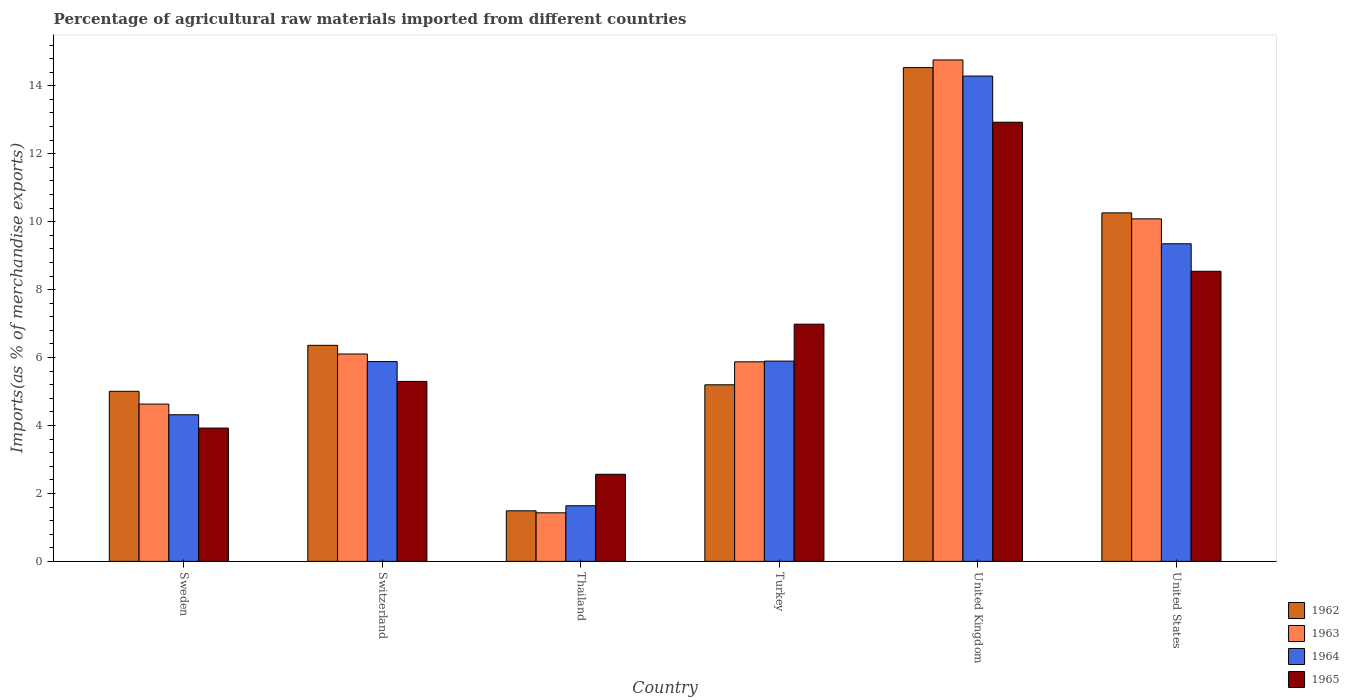How many different coloured bars are there?
Make the answer very short. 4. How many bars are there on the 5th tick from the left?
Provide a succinct answer. 4. What is the percentage of imports to different countries in 1964 in Sweden?
Provide a succinct answer. 4.32. Across all countries, what is the maximum percentage of imports to different countries in 1963?
Provide a short and direct response. 14.76. Across all countries, what is the minimum percentage of imports to different countries in 1964?
Ensure brevity in your answer.  1.64. In which country was the percentage of imports to different countries in 1962 minimum?
Give a very brief answer. Thailand. What is the total percentage of imports to different countries in 1964 in the graph?
Offer a very short reply. 41.37. What is the difference between the percentage of imports to different countries in 1965 in Thailand and that in United States?
Give a very brief answer. -5.98. What is the difference between the percentage of imports to different countries in 1965 in Thailand and the percentage of imports to different countries in 1964 in Sweden?
Offer a very short reply. -1.75. What is the average percentage of imports to different countries in 1962 per country?
Keep it short and to the point. 7.14. What is the difference between the percentage of imports to different countries of/in 1962 and percentage of imports to different countries of/in 1964 in Thailand?
Ensure brevity in your answer.  -0.15. What is the ratio of the percentage of imports to different countries in 1965 in Switzerland to that in Thailand?
Offer a terse response. 2.07. What is the difference between the highest and the second highest percentage of imports to different countries in 1963?
Keep it short and to the point. -4.68. What is the difference between the highest and the lowest percentage of imports to different countries in 1963?
Give a very brief answer. 13.33. Is the sum of the percentage of imports to different countries in 1962 in Sweden and Thailand greater than the maximum percentage of imports to different countries in 1964 across all countries?
Offer a terse response. No. Is it the case that in every country, the sum of the percentage of imports to different countries in 1962 and percentage of imports to different countries in 1964 is greater than the percentage of imports to different countries in 1963?
Offer a terse response. Yes. How many bars are there?
Provide a short and direct response. 24. Are all the bars in the graph horizontal?
Your response must be concise. No. What is the difference between two consecutive major ticks on the Y-axis?
Your response must be concise. 2. Does the graph contain grids?
Keep it short and to the point. No. How are the legend labels stacked?
Offer a terse response. Vertical. What is the title of the graph?
Your answer should be compact. Percentage of agricultural raw materials imported from different countries. What is the label or title of the X-axis?
Ensure brevity in your answer.  Country. What is the label or title of the Y-axis?
Keep it short and to the point. Imports(as % of merchandise exports). What is the Imports(as % of merchandise exports) in 1962 in Sweden?
Keep it short and to the point. 5.01. What is the Imports(as % of merchandise exports) in 1963 in Sweden?
Give a very brief answer. 4.63. What is the Imports(as % of merchandise exports) of 1964 in Sweden?
Provide a succinct answer. 4.32. What is the Imports(as % of merchandise exports) in 1965 in Sweden?
Provide a succinct answer. 3.92. What is the Imports(as % of merchandise exports) in 1962 in Switzerland?
Make the answer very short. 6.36. What is the Imports(as % of merchandise exports) in 1963 in Switzerland?
Your answer should be very brief. 6.1. What is the Imports(as % of merchandise exports) in 1964 in Switzerland?
Ensure brevity in your answer.  5.88. What is the Imports(as % of merchandise exports) of 1965 in Switzerland?
Keep it short and to the point. 5.3. What is the Imports(as % of merchandise exports) in 1962 in Thailand?
Give a very brief answer. 1.49. What is the Imports(as % of merchandise exports) of 1963 in Thailand?
Make the answer very short. 1.43. What is the Imports(as % of merchandise exports) in 1964 in Thailand?
Provide a short and direct response. 1.64. What is the Imports(as % of merchandise exports) in 1965 in Thailand?
Offer a terse response. 2.56. What is the Imports(as % of merchandise exports) in 1962 in Turkey?
Your answer should be very brief. 5.2. What is the Imports(as % of merchandise exports) of 1963 in Turkey?
Give a very brief answer. 5.87. What is the Imports(as % of merchandise exports) of 1964 in Turkey?
Give a very brief answer. 5.9. What is the Imports(as % of merchandise exports) in 1965 in Turkey?
Provide a succinct answer. 6.98. What is the Imports(as % of merchandise exports) of 1962 in United Kingdom?
Provide a succinct answer. 14.54. What is the Imports(as % of merchandise exports) of 1963 in United Kingdom?
Make the answer very short. 14.76. What is the Imports(as % of merchandise exports) in 1964 in United Kingdom?
Make the answer very short. 14.29. What is the Imports(as % of merchandise exports) of 1965 in United Kingdom?
Your answer should be compact. 12.93. What is the Imports(as % of merchandise exports) of 1962 in United States?
Your answer should be compact. 10.26. What is the Imports(as % of merchandise exports) in 1963 in United States?
Offer a terse response. 10.08. What is the Imports(as % of merchandise exports) in 1964 in United States?
Offer a terse response. 9.35. What is the Imports(as % of merchandise exports) in 1965 in United States?
Keep it short and to the point. 8.54. Across all countries, what is the maximum Imports(as % of merchandise exports) of 1962?
Your answer should be very brief. 14.54. Across all countries, what is the maximum Imports(as % of merchandise exports) in 1963?
Offer a very short reply. 14.76. Across all countries, what is the maximum Imports(as % of merchandise exports) in 1964?
Keep it short and to the point. 14.29. Across all countries, what is the maximum Imports(as % of merchandise exports) of 1965?
Your response must be concise. 12.93. Across all countries, what is the minimum Imports(as % of merchandise exports) of 1962?
Provide a short and direct response. 1.49. Across all countries, what is the minimum Imports(as % of merchandise exports) in 1963?
Your answer should be compact. 1.43. Across all countries, what is the minimum Imports(as % of merchandise exports) in 1964?
Ensure brevity in your answer.  1.64. Across all countries, what is the minimum Imports(as % of merchandise exports) of 1965?
Offer a terse response. 2.56. What is the total Imports(as % of merchandise exports) in 1962 in the graph?
Offer a terse response. 42.85. What is the total Imports(as % of merchandise exports) of 1963 in the graph?
Offer a terse response. 42.88. What is the total Imports(as % of merchandise exports) of 1964 in the graph?
Offer a terse response. 41.37. What is the total Imports(as % of merchandise exports) of 1965 in the graph?
Your response must be concise. 40.24. What is the difference between the Imports(as % of merchandise exports) in 1962 in Sweden and that in Switzerland?
Your answer should be very brief. -1.35. What is the difference between the Imports(as % of merchandise exports) in 1963 in Sweden and that in Switzerland?
Your response must be concise. -1.47. What is the difference between the Imports(as % of merchandise exports) of 1964 in Sweden and that in Switzerland?
Ensure brevity in your answer.  -1.57. What is the difference between the Imports(as % of merchandise exports) in 1965 in Sweden and that in Switzerland?
Your response must be concise. -1.37. What is the difference between the Imports(as % of merchandise exports) of 1962 in Sweden and that in Thailand?
Give a very brief answer. 3.52. What is the difference between the Imports(as % of merchandise exports) in 1963 in Sweden and that in Thailand?
Your answer should be very brief. 3.2. What is the difference between the Imports(as % of merchandise exports) of 1964 in Sweden and that in Thailand?
Your answer should be very brief. 2.68. What is the difference between the Imports(as % of merchandise exports) in 1965 in Sweden and that in Thailand?
Make the answer very short. 1.36. What is the difference between the Imports(as % of merchandise exports) of 1962 in Sweden and that in Turkey?
Provide a short and direct response. -0.19. What is the difference between the Imports(as % of merchandise exports) of 1963 in Sweden and that in Turkey?
Your answer should be compact. -1.24. What is the difference between the Imports(as % of merchandise exports) of 1964 in Sweden and that in Turkey?
Your answer should be very brief. -1.58. What is the difference between the Imports(as % of merchandise exports) in 1965 in Sweden and that in Turkey?
Give a very brief answer. -3.06. What is the difference between the Imports(as % of merchandise exports) of 1962 in Sweden and that in United Kingdom?
Offer a terse response. -9.53. What is the difference between the Imports(as % of merchandise exports) of 1963 in Sweden and that in United Kingdom?
Provide a short and direct response. -10.13. What is the difference between the Imports(as % of merchandise exports) of 1964 in Sweden and that in United Kingdom?
Offer a terse response. -9.97. What is the difference between the Imports(as % of merchandise exports) in 1965 in Sweden and that in United Kingdom?
Offer a terse response. -9. What is the difference between the Imports(as % of merchandise exports) of 1962 in Sweden and that in United States?
Offer a terse response. -5.25. What is the difference between the Imports(as % of merchandise exports) of 1963 in Sweden and that in United States?
Provide a succinct answer. -5.45. What is the difference between the Imports(as % of merchandise exports) in 1964 in Sweden and that in United States?
Your answer should be compact. -5.03. What is the difference between the Imports(as % of merchandise exports) in 1965 in Sweden and that in United States?
Offer a terse response. -4.62. What is the difference between the Imports(as % of merchandise exports) in 1962 in Switzerland and that in Thailand?
Offer a terse response. 4.87. What is the difference between the Imports(as % of merchandise exports) in 1963 in Switzerland and that in Thailand?
Your response must be concise. 4.68. What is the difference between the Imports(as % of merchandise exports) in 1964 in Switzerland and that in Thailand?
Offer a terse response. 4.24. What is the difference between the Imports(as % of merchandise exports) of 1965 in Switzerland and that in Thailand?
Make the answer very short. 2.73. What is the difference between the Imports(as % of merchandise exports) in 1962 in Switzerland and that in Turkey?
Give a very brief answer. 1.16. What is the difference between the Imports(as % of merchandise exports) of 1963 in Switzerland and that in Turkey?
Provide a succinct answer. 0.23. What is the difference between the Imports(as % of merchandise exports) in 1964 in Switzerland and that in Turkey?
Your answer should be compact. -0.01. What is the difference between the Imports(as % of merchandise exports) in 1965 in Switzerland and that in Turkey?
Your response must be concise. -1.69. What is the difference between the Imports(as % of merchandise exports) in 1962 in Switzerland and that in United Kingdom?
Your response must be concise. -8.18. What is the difference between the Imports(as % of merchandise exports) of 1963 in Switzerland and that in United Kingdom?
Ensure brevity in your answer.  -8.66. What is the difference between the Imports(as % of merchandise exports) in 1964 in Switzerland and that in United Kingdom?
Offer a very short reply. -8.41. What is the difference between the Imports(as % of merchandise exports) of 1965 in Switzerland and that in United Kingdom?
Give a very brief answer. -7.63. What is the difference between the Imports(as % of merchandise exports) in 1962 in Switzerland and that in United States?
Give a very brief answer. -3.9. What is the difference between the Imports(as % of merchandise exports) of 1963 in Switzerland and that in United States?
Offer a terse response. -3.98. What is the difference between the Imports(as % of merchandise exports) in 1964 in Switzerland and that in United States?
Your response must be concise. -3.47. What is the difference between the Imports(as % of merchandise exports) of 1965 in Switzerland and that in United States?
Ensure brevity in your answer.  -3.24. What is the difference between the Imports(as % of merchandise exports) of 1962 in Thailand and that in Turkey?
Provide a short and direct response. -3.71. What is the difference between the Imports(as % of merchandise exports) of 1963 in Thailand and that in Turkey?
Offer a terse response. -4.45. What is the difference between the Imports(as % of merchandise exports) in 1964 in Thailand and that in Turkey?
Your response must be concise. -4.26. What is the difference between the Imports(as % of merchandise exports) in 1965 in Thailand and that in Turkey?
Provide a succinct answer. -4.42. What is the difference between the Imports(as % of merchandise exports) of 1962 in Thailand and that in United Kingdom?
Your answer should be very brief. -13.05. What is the difference between the Imports(as % of merchandise exports) of 1963 in Thailand and that in United Kingdom?
Your answer should be compact. -13.33. What is the difference between the Imports(as % of merchandise exports) of 1964 in Thailand and that in United Kingdom?
Provide a succinct answer. -12.65. What is the difference between the Imports(as % of merchandise exports) in 1965 in Thailand and that in United Kingdom?
Keep it short and to the point. -10.36. What is the difference between the Imports(as % of merchandise exports) of 1962 in Thailand and that in United States?
Your answer should be compact. -8.77. What is the difference between the Imports(as % of merchandise exports) of 1963 in Thailand and that in United States?
Your answer should be very brief. -8.65. What is the difference between the Imports(as % of merchandise exports) in 1964 in Thailand and that in United States?
Offer a terse response. -7.71. What is the difference between the Imports(as % of merchandise exports) of 1965 in Thailand and that in United States?
Your response must be concise. -5.98. What is the difference between the Imports(as % of merchandise exports) of 1962 in Turkey and that in United Kingdom?
Provide a succinct answer. -9.34. What is the difference between the Imports(as % of merchandise exports) of 1963 in Turkey and that in United Kingdom?
Your answer should be compact. -8.89. What is the difference between the Imports(as % of merchandise exports) of 1964 in Turkey and that in United Kingdom?
Provide a succinct answer. -8.39. What is the difference between the Imports(as % of merchandise exports) in 1965 in Turkey and that in United Kingdom?
Your answer should be very brief. -5.95. What is the difference between the Imports(as % of merchandise exports) in 1962 in Turkey and that in United States?
Provide a succinct answer. -5.06. What is the difference between the Imports(as % of merchandise exports) in 1963 in Turkey and that in United States?
Offer a terse response. -4.21. What is the difference between the Imports(as % of merchandise exports) of 1964 in Turkey and that in United States?
Provide a succinct answer. -3.46. What is the difference between the Imports(as % of merchandise exports) in 1965 in Turkey and that in United States?
Your answer should be very brief. -1.56. What is the difference between the Imports(as % of merchandise exports) of 1962 in United Kingdom and that in United States?
Offer a terse response. 4.28. What is the difference between the Imports(as % of merchandise exports) of 1963 in United Kingdom and that in United States?
Keep it short and to the point. 4.68. What is the difference between the Imports(as % of merchandise exports) of 1964 in United Kingdom and that in United States?
Provide a short and direct response. 4.94. What is the difference between the Imports(as % of merchandise exports) in 1965 in United Kingdom and that in United States?
Your response must be concise. 4.39. What is the difference between the Imports(as % of merchandise exports) in 1962 in Sweden and the Imports(as % of merchandise exports) in 1963 in Switzerland?
Give a very brief answer. -1.1. What is the difference between the Imports(as % of merchandise exports) of 1962 in Sweden and the Imports(as % of merchandise exports) of 1964 in Switzerland?
Your answer should be very brief. -0.88. What is the difference between the Imports(as % of merchandise exports) of 1962 in Sweden and the Imports(as % of merchandise exports) of 1965 in Switzerland?
Offer a very short reply. -0.29. What is the difference between the Imports(as % of merchandise exports) of 1963 in Sweden and the Imports(as % of merchandise exports) of 1964 in Switzerland?
Your answer should be compact. -1.25. What is the difference between the Imports(as % of merchandise exports) of 1963 in Sweden and the Imports(as % of merchandise exports) of 1965 in Switzerland?
Give a very brief answer. -0.67. What is the difference between the Imports(as % of merchandise exports) of 1964 in Sweden and the Imports(as % of merchandise exports) of 1965 in Switzerland?
Provide a succinct answer. -0.98. What is the difference between the Imports(as % of merchandise exports) of 1962 in Sweden and the Imports(as % of merchandise exports) of 1963 in Thailand?
Give a very brief answer. 3.58. What is the difference between the Imports(as % of merchandise exports) in 1962 in Sweden and the Imports(as % of merchandise exports) in 1964 in Thailand?
Your answer should be compact. 3.37. What is the difference between the Imports(as % of merchandise exports) in 1962 in Sweden and the Imports(as % of merchandise exports) in 1965 in Thailand?
Offer a terse response. 2.44. What is the difference between the Imports(as % of merchandise exports) in 1963 in Sweden and the Imports(as % of merchandise exports) in 1964 in Thailand?
Make the answer very short. 2.99. What is the difference between the Imports(as % of merchandise exports) in 1963 in Sweden and the Imports(as % of merchandise exports) in 1965 in Thailand?
Give a very brief answer. 2.07. What is the difference between the Imports(as % of merchandise exports) in 1964 in Sweden and the Imports(as % of merchandise exports) in 1965 in Thailand?
Your response must be concise. 1.75. What is the difference between the Imports(as % of merchandise exports) of 1962 in Sweden and the Imports(as % of merchandise exports) of 1963 in Turkey?
Keep it short and to the point. -0.87. What is the difference between the Imports(as % of merchandise exports) in 1962 in Sweden and the Imports(as % of merchandise exports) in 1964 in Turkey?
Give a very brief answer. -0.89. What is the difference between the Imports(as % of merchandise exports) in 1962 in Sweden and the Imports(as % of merchandise exports) in 1965 in Turkey?
Provide a succinct answer. -1.98. What is the difference between the Imports(as % of merchandise exports) of 1963 in Sweden and the Imports(as % of merchandise exports) of 1964 in Turkey?
Your response must be concise. -1.27. What is the difference between the Imports(as % of merchandise exports) of 1963 in Sweden and the Imports(as % of merchandise exports) of 1965 in Turkey?
Ensure brevity in your answer.  -2.35. What is the difference between the Imports(as % of merchandise exports) in 1964 in Sweden and the Imports(as % of merchandise exports) in 1965 in Turkey?
Give a very brief answer. -2.67. What is the difference between the Imports(as % of merchandise exports) in 1962 in Sweden and the Imports(as % of merchandise exports) in 1963 in United Kingdom?
Offer a very short reply. -9.76. What is the difference between the Imports(as % of merchandise exports) in 1962 in Sweden and the Imports(as % of merchandise exports) in 1964 in United Kingdom?
Keep it short and to the point. -9.28. What is the difference between the Imports(as % of merchandise exports) in 1962 in Sweden and the Imports(as % of merchandise exports) in 1965 in United Kingdom?
Provide a short and direct response. -7.92. What is the difference between the Imports(as % of merchandise exports) of 1963 in Sweden and the Imports(as % of merchandise exports) of 1964 in United Kingdom?
Your answer should be compact. -9.66. What is the difference between the Imports(as % of merchandise exports) of 1963 in Sweden and the Imports(as % of merchandise exports) of 1965 in United Kingdom?
Provide a short and direct response. -8.3. What is the difference between the Imports(as % of merchandise exports) of 1964 in Sweden and the Imports(as % of merchandise exports) of 1965 in United Kingdom?
Provide a succinct answer. -8.61. What is the difference between the Imports(as % of merchandise exports) in 1962 in Sweden and the Imports(as % of merchandise exports) in 1963 in United States?
Offer a very short reply. -5.08. What is the difference between the Imports(as % of merchandise exports) in 1962 in Sweden and the Imports(as % of merchandise exports) in 1964 in United States?
Keep it short and to the point. -4.34. What is the difference between the Imports(as % of merchandise exports) of 1962 in Sweden and the Imports(as % of merchandise exports) of 1965 in United States?
Make the answer very short. -3.53. What is the difference between the Imports(as % of merchandise exports) of 1963 in Sweden and the Imports(as % of merchandise exports) of 1964 in United States?
Offer a very short reply. -4.72. What is the difference between the Imports(as % of merchandise exports) of 1963 in Sweden and the Imports(as % of merchandise exports) of 1965 in United States?
Provide a succinct answer. -3.91. What is the difference between the Imports(as % of merchandise exports) of 1964 in Sweden and the Imports(as % of merchandise exports) of 1965 in United States?
Your answer should be very brief. -4.22. What is the difference between the Imports(as % of merchandise exports) of 1962 in Switzerland and the Imports(as % of merchandise exports) of 1963 in Thailand?
Make the answer very short. 4.93. What is the difference between the Imports(as % of merchandise exports) of 1962 in Switzerland and the Imports(as % of merchandise exports) of 1964 in Thailand?
Your answer should be very brief. 4.72. What is the difference between the Imports(as % of merchandise exports) in 1962 in Switzerland and the Imports(as % of merchandise exports) in 1965 in Thailand?
Provide a short and direct response. 3.8. What is the difference between the Imports(as % of merchandise exports) of 1963 in Switzerland and the Imports(as % of merchandise exports) of 1964 in Thailand?
Keep it short and to the point. 4.47. What is the difference between the Imports(as % of merchandise exports) in 1963 in Switzerland and the Imports(as % of merchandise exports) in 1965 in Thailand?
Provide a succinct answer. 3.54. What is the difference between the Imports(as % of merchandise exports) in 1964 in Switzerland and the Imports(as % of merchandise exports) in 1965 in Thailand?
Make the answer very short. 3.32. What is the difference between the Imports(as % of merchandise exports) of 1962 in Switzerland and the Imports(as % of merchandise exports) of 1963 in Turkey?
Your answer should be compact. 0.49. What is the difference between the Imports(as % of merchandise exports) of 1962 in Switzerland and the Imports(as % of merchandise exports) of 1964 in Turkey?
Your answer should be compact. 0.46. What is the difference between the Imports(as % of merchandise exports) in 1962 in Switzerland and the Imports(as % of merchandise exports) in 1965 in Turkey?
Provide a short and direct response. -0.62. What is the difference between the Imports(as % of merchandise exports) of 1963 in Switzerland and the Imports(as % of merchandise exports) of 1964 in Turkey?
Your answer should be compact. 0.21. What is the difference between the Imports(as % of merchandise exports) in 1963 in Switzerland and the Imports(as % of merchandise exports) in 1965 in Turkey?
Ensure brevity in your answer.  -0.88. What is the difference between the Imports(as % of merchandise exports) in 1964 in Switzerland and the Imports(as % of merchandise exports) in 1965 in Turkey?
Give a very brief answer. -1.1. What is the difference between the Imports(as % of merchandise exports) of 1962 in Switzerland and the Imports(as % of merchandise exports) of 1963 in United Kingdom?
Your answer should be compact. -8.4. What is the difference between the Imports(as % of merchandise exports) of 1962 in Switzerland and the Imports(as % of merchandise exports) of 1964 in United Kingdom?
Your answer should be very brief. -7.93. What is the difference between the Imports(as % of merchandise exports) in 1962 in Switzerland and the Imports(as % of merchandise exports) in 1965 in United Kingdom?
Your answer should be very brief. -6.57. What is the difference between the Imports(as % of merchandise exports) in 1963 in Switzerland and the Imports(as % of merchandise exports) in 1964 in United Kingdom?
Provide a short and direct response. -8.18. What is the difference between the Imports(as % of merchandise exports) in 1963 in Switzerland and the Imports(as % of merchandise exports) in 1965 in United Kingdom?
Provide a short and direct response. -6.82. What is the difference between the Imports(as % of merchandise exports) of 1964 in Switzerland and the Imports(as % of merchandise exports) of 1965 in United Kingdom?
Provide a succinct answer. -7.05. What is the difference between the Imports(as % of merchandise exports) in 1962 in Switzerland and the Imports(as % of merchandise exports) in 1963 in United States?
Provide a succinct answer. -3.72. What is the difference between the Imports(as % of merchandise exports) of 1962 in Switzerland and the Imports(as % of merchandise exports) of 1964 in United States?
Provide a short and direct response. -2.99. What is the difference between the Imports(as % of merchandise exports) in 1962 in Switzerland and the Imports(as % of merchandise exports) in 1965 in United States?
Your answer should be very brief. -2.18. What is the difference between the Imports(as % of merchandise exports) of 1963 in Switzerland and the Imports(as % of merchandise exports) of 1964 in United States?
Make the answer very short. -3.25. What is the difference between the Imports(as % of merchandise exports) of 1963 in Switzerland and the Imports(as % of merchandise exports) of 1965 in United States?
Your response must be concise. -2.44. What is the difference between the Imports(as % of merchandise exports) of 1964 in Switzerland and the Imports(as % of merchandise exports) of 1965 in United States?
Give a very brief answer. -2.66. What is the difference between the Imports(as % of merchandise exports) in 1962 in Thailand and the Imports(as % of merchandise exports) in 1963 in Turkey?
Make the answer very short. -4.39. What is the difference between the Imports(as % of merchandise exports) in 1962 in Thailand and the Imports(as % of merchandise exports) in 1964 in Turkey?
Ensure brevity in your answer.  -4.41. What is the difference between the Imports(as % of merchandise exports) in 1962 in Thailand and the Imports(as % of merchandise exports) in 1965 in Turkey?
Give a very brief answer. -5.49. What is the difference between the Imports(as % of merchandise exports) of 1963 in Thailand and the Imports(as % of merchandise exports) of 1964 in Turkey?
Make the answer very short. -4.47. What is the difference between the Imports(as % of merchandise exports) in 1963 in Thailand and the Imports(as % of merchandise exports) in 1965 in Turkey?
Provide a succinct answer. -5.55. What is the difference between the Imports(as % of merchandise exports) in 1964 in Thailand and the Imports(as % of merchandise exports) in 1965 in Turkey?
Provide a succinct answer. -5.35. What is the difference between the Imports(as % of merchandise exports) of 1962 in Thailand and the Imports(as % of merchandise exports) of 1963 in United Kingdom?
Offer a very short reply. -13.27. What is the difference between the Imports(as % of merchandise exports) of 1962 in Thailand and the Imports(as % of merchandise exports) of 1964 in United Kingdom?
Offer a terse response. -12.8. What is the difference between the Imports(as % of merchandise exports) of 1962 in Thailand and the Imports(as % of merchandise exports) of 1965 in United Kingdom?
Provide a succinct answer. -11.44. What is the difference between the Imports(as % of merchandise exports) of 1963 in Thailand and the Imports(as % of merchandise exports) of 1964 in United Kingdom?
Keep it short and to the point. -12.86. What is the difference between the Imports(as % of merchandise exports) of 1963 in Thailand and the Imports(as % of merchandise exports) of 1965 in United Kingdom?
Your answer should be very brief. -11.5. What is the difference between the Imports(as % of merchandise exports) of 1964 in Thailand and the Imports(as % of merchandise exports) of 1965 in United Kingdom?
Provide a succinct answer. -11.29. What is the difference between the Imports(as % of merchandise exports) of 1962 in Thailand and the Imports(as % of merchandise exports) of 1963 in United States?
Provide a short and direct response. -8.59. What is the difference between the Imports(as % of merchandise exports) of 1962 in Thailand and the Imports(as % of merchandise exports) of 1964 in United States?
Your answer should be very brief. -7.86. What is the difference between the Imports(as % of merchandise exports) in 1962 in Thailand and the Imports(as % of merchandise exports) in 1965 in United States?
Make the answer very short. -7.05. What is the difference between the Imports(as % of merchandise exports) in 1963 in Thailand and the Imports(as % of merchandise exports) in 1964 in United States?
Offer a terse response. -7.92. What is the difference between the Imports(as % of merchandise exports) in 1963 in Thailand and the Imports(as % of merchandise exports) in 1965 in United States?
Your response must be concise. -7.11. What is the difference between the Imports(as % of merchandise exports) of 1964 in Thailand and the Imports(as % of merchandise exports) of 1965 in United States?
Make the answer very short. -6.9. What is the difference between the Imports(as % of merchandise exports) of 1962 in Turkey and the Imports(as % of merchandise exports) of 1963 in United Kingdom?
Make the answer very short. -9.56. What is the difference between the Imports(as % of merchandise exports) in 1962 in Turkey and the Imports(as % of merchandise exports) in 1964 in United Kingdom?
Give a very brief answer. -9.09. What is the difference between the Imports(as % of merchandise exports) in 1962 in Turkey and the Imports(as % of merchandise exports) in 1965 in United Kingdom?
Provide a succinct answer. -7.73. What is the difference between the Imports(as % of merchandise exports) of 1963 in Turkey and the Imports(as % of merchandise exports) of 1964 in United Kingdom?
Provide a succinct answer. -8.41. What is the difference between the Imports(as % of merchandise exports) of 1963 in Turkey and the Imports(as % of merchandise exports) of 1965 in United Kingdom?
Your answer should be compact. -7.05. What is the difference between the Imports(as % of merchandise exports) in 1964 in Turkey and the Imports(as % of merchandise exports) in 1965 in United Kingdom?
Ensure brevity in your answer.  -7.03. What is the difference between the Imports(as % of merchandise exports) of 1962 in Turkey and the Imports(as % of merchandise exports) of 1963 in United States?
Make the answer very short. -4.89. What is the difference between the Imports(as % of merchandise exports) of 1962 in Turkey and the Imports(as % of merchandise exports) of 1964 in United States?
Your response must be concise. -4.15. What is the difference between the Imports(as % of merchandise exports) in 1962 in Turkey and the Imports(as % of merchandise exports) in 1965 in United States?
Offer a very short reply. -3.34. What is the difference between the Imports(as % of merchandise exports) of 1963 in Turkey and the Imports(as % of merchandise exports) of 1964 in United States?
Keep it short and to the point. -3.48. What is the difference between the Imports(as % of merchandise exports) of 1963 in Turkey and the Imports(as % of merchandise exports) of 1965 in United States?
Keep it short and to the point. -2.67. What is the difference between the Imports(as % of merchandise exports) in 1964 in Turkey and the Imports(as % of merchandise exports) in 1965 in United States?
Your answer should be compact. -2.65. What is the difference between the Imports(as % of merchandise exports) of 1962 in United Kingdom and the Imports(as % of merchandise exports) of 1963 in United States?
Your answer should be compact. 4.45. What is the difference between the Imports(as % of merchandise exports) of 1962 in United Kingdom and the Imports(as % of merchandise exports) of 1964 in United States?
Your answer should be very brief. 5.19. What is the difference between the Imports(as % of merchandise exports) of 1962 in United Kingdom and the Imports(as % of merchandise exports) of 1965 in United States?
Ensure brevity in your answer.  5.99. What is the difference between the Imports(as % of merchandise exports) in 1963 in United Kingdom and the Imports(as % of merchandise exports) in 1964 in United States?
Provide a short and direct response. 5.41. What is the difference between the Imports(as % of merchandise exports) in 1963 in United Kingdom and the Imports(as % of merchandise exports) in 1965 in United States?
Provide a short and direct response. 6.22. What is the difference between the Imports(as % of merchandise exports) in 1964 in United Kingdom and the Imports(as % of merchandise exports) in 1965 in United States?
Ensure brevity in your answer.  5.75. What is the average Imports(as % of merchandise exports) of 1962 per country?
Your response must be concise. 7.14. What is the average Imports(as % of merchandise exports) of 1963 per country?
Your answer should be compact. 7.15. What is the average Imports(as % of merchandise exports) of 1964 per country?
Your answer should be compact. 6.89. What is the average Imports(as % of merchandise exports) in 1965 per country?
Your response must be concise. 6.71. What is the difference between the Imports(as % of merchandise exports) of 1962 and Imports(as % of merchandise exports) of 1963 in Sweden?
Provide a short and direct response. 0.38. What is the difference between the Imports(as % of merchandise exports) of 1962 and Imports(as % of merchandise exports) of 1964 in Sweden?
Offer a terse response. 0.69. What is the difference between the Imports(as % of merchandise exports) in 1962 and Imports(as % of merchandise exports) in 1965 in Sweden?
Offer a very short reply. 1.08. What is the difference between the Imports(as % of merchandise exports) of 1963 and Imports(as % of merchandise exports) of 1964 in Sweden?
Keep it short and to the point. 0.31. What is the difference between the Imports(as % of merchandise exports) in 1963 and Imports(as % of merchandise exports) in 1965 in Sweden?
Provide a succinct answer. 0.71. What is the difference between the Imports(as % of merchandise exports) of 1964 and Imports(as % of merchandise exports) of 1965 in Sweden?
Your answer should be very brief. 0.39. What is the difference between the Imports(as % of merchandise exports) in 1962 and Imports(as % of merchandise exports) in 1963 in Switzerland?
Your answer should be compact. 0.26. What is the difference between the Imports(as % of merchandise exports) in 1962 and Imports(as % of merchandise exports) in 1964 in Switzerland?
Keep it short and to the point. 0.48. What is the difference between the Imports(as % of merchandise exports) in 1962 and Imports(as % of merchandise exports) in 1965 in Switzerland?
Give a very brief answer. 1.06. What is the difference between the Imports(as % of merchandise exports) of 1963 and Imports(as % of merchandise exports) of 1964 in Switzerland?
Your response must be concise. 0.22. What is the difference between the Imports(as % of merchandise exports) in 1963 and Imports(as % of merchandise exports) in 1965 in Switzerland?
Your answer should be compact. 0.81. What is the difference between the Imports(as % of merchandise exports) of 1964 and Imports(as % of merchandise exports) of 1965 in Switzerland?
Keep it short and to the point. 0.58. What is the difference between the Imports(as % of merchandise exports) in 1962 and Imports(as % of merchandise exports) in 1963 in Thailand?
Your response must be concise. 0.06. What is the difference between the Imports(as % of merchandise exports) in 1962 and Imports(as % of merchandise exports) in 1964 in Thailand?
Provide a short and direct response. -0.15. What is the difference between the Imports(as % of merchandise exports) of 1962 and Imports(as % of merchandise exports) of 1965 in Thailand?
Provide a short and direct response. -1.08. What is the difference between the Imports(as % of merchandise exports) of 1963 and Imports(as % of merchandise exports) of 1964 in Thailand?
Provide a succinct answer. -0.21. What is the difference between the Imports(as % of merchandise exports) in 1963 and Imports(as % of merchandise exports) in 1965 in Thailand?
Your answer should be very brief. -1.13. What is the difference between the Imports(as % of merchandise exports) in 1964 and Imports(as % of merchandise exports) in 1965 in Thailand?
Make the answer very short. -0.93. What is the difference between the Imports(as % of merchandise exports) of 1962 and Imports(as % of merchandise exports) of 1963 in Turkey?
Make the answer very short. -0.68. What is the difference between the Imports(as % of merchandise exports) in 1962 and Imports(as % of merchandise exports) in 1964 in Turkey?
Your answer should be very brief. -0.7. What is the difference between the Imports(as % of merchandise exports) in 1962 and Imports(as % of merchandise exports) in 1965 in Turkey?
Offer a very short reply. -1.78. What is the difference between the Imports(as % of merchandise exports) of 1963 and Imports(as % of merchandise exports) of 1964 in Turkey?
Your response must be concise. -0.02. What is the difference between the Imports(as % of merchandise exports) in 1963 and Imports(as % of merchandise exports) in 1965 in Turkey?
Make the answer very short. -1.11. What is the difference between the Imports(as % of merchandise exports) in 1964 and Imports(as % of merchandise exports) in 1965 in Turkey?
Ensure brevity in your answer.  -1.09. What is the difference between the Imports(as % of merchandise exports) in 1962 and Imports(as % of merchandise exports) in 1963 in United Kingdom?
Provide a succinct answer. -0.23. What is the difference between the Imports(as % of merchandise exports) in 1962 and Imports(as % of merchandise exports) in 1964 in United Kingdom?
Make the answer very short. 0.25. What is the difference between the Imports(as % of merchandise exports) of 1962 and Imports(as % of merchandise exports) of 1965 in United Kingdom?
Provide a succinct answer. 1.61. What is the difference between the Imports(as % of merchandise exports) of 1963 and Imports(as % of merchandise exports) of 1964 in United Kingdom?
Make the answer very short. 0.47. What is the difference between the Imports(as % of merchandise exports) in 1963 and Imports(as % of merchandise exports) in 1965 in United Kingdom?
Keep it short and to the point. 1.83. What is the difference between the Imports(as % of merchandise exports) of 1964 and Imports(as % of merchandise exports) of 1965 in United Kingdom?
Provide a short and direct response. 1.36. What is the difference between the Imports(as % of merchandise exports) in 1962 and Imports(as % of merchandise exports) in 1963 in United States?
Give a very brief answer. 0.18. What is the difference between the Imports(as % of merchandise exports) of 1962 and Imports(as % of merchandise exports) of 1964 in United States?
Offer a very short reply. 0.91. What is the difference between the Imports(as % of merchandise exports) of 1962 and Imports(as % of merchandise exports) of 1965 in United States?
Ensure brevity in your answer.  1.72. What is the difference between the Imports(as % of merchandise exports) of 1963 and Imports(as % of merchandise exports) of 1964 in United States?
Keep it short and to the point. 0.73. What is the difference between the Imports(as % of merchandise exports) in 1963 and Imports(as % of merchandise exports) in 1965 in United States?
Provide a succinct answer. 1.54. What is the difference between the Imports(as % of merchandise exports) of 1964 and Imports(as % of merchandise exports) of 1965 in United States?
Ensure brevity in your answer.  0.81. What is the ratio of the Imports(as % of merchandise exports) of 1962 in Sweden to that in Switzerland?
Keep it short and to the point. 0.79. What is the ratio of the Imports(as % of merchandise exports) in 1963 in Sweden to that in Switzerland?
Your response must be concise. 0.76. What is the ratio of the Imports(as % of merchandise exports) in 1964 in Sweden to that in Switzerland?
Offer a very short reply. 0.73. What is the ratio of the Imports(as % of merchandise exports) of 1965 in Sweden to that in Switzerland?
Make the answer very short. 0.74. What is the ratio of the Imports(as % of merchandise exports) of 1962 in Sweden to that in Thailand?
Offer a very short reply. 3.36. What is the ratio of the Imports(as % of merchandise exports) of 1963 in Sweden to that in Thailand?
Provide a succinct answer. 3.24. What is the ratio of the Imports(as % of merchandise exports) in 1964 in Sweden to that in Thailand?
Offer a very short reply. 2.64. What is the ratio of the Imports(as % of merchandise exports) of 1965 in Sweden to that in Thailand?
Keep it short and to the point. 1.53. What is the ratio of the Imports(as % of merchandise exports) of 1963 in Sweden to that in Turkey?
Give a very brief answer. 0.79. What is the ratio of the Imports(as % of merchandise exports) in 1964 in Sweden to that in Turkey?
Your response must be concise. 0.73. What is the ratio of the Imports(as % of merchandise exports) in 1965 in Sweden to that in Turkey?
Your response must be concise. 0.56. What is the ratio of the Imports(as % of merchandise exports) in 1962 in Sweden to that in United Kingdom?
Offer a terse response. 0.34. What is the ratio of the Imports(as % of merchandise exports) of 1963 in Sweden to that in United Kingdom?
Keep it short and to the point. 0.31. What is the ratio of the Imports(as % of merchandise exports) in 1964 in Sweden to that in United Kingdom?
Your answer should be very brief. 0.3. What is the ratio of the Imports(as % of merchandise exports) of 1965 in Sweden to that in United Kingdom?
Your answer should be very brief. 0.3. What is the ratio of the Imports(as % of merchandise exports) in 1962 in Sweden to that in United States?
Make the answer very short. 0.49. What is the ratio of the Imports(as % of merchandise exports) in 1963 in Sweden to that in United States?
Offer a very short reply. 0.46. What is the ratio of the Imports(as % of merchandise exports) in 1964 in Sweden to that in United States?
Keep it short and to the point. 0.46. What is the ratio of the Imports(as % of merchandise exports) in 1965 in Sweden to that in United States?
Give a very brief answer. 0.46. What is the ratio of the Imports(as % of merchandise exports) of 1962 in Switzerland to that in Thailand?
Offer a very short reply. 4.27. What is the ratio of the Imports(as % of merchandise exports) of 1963 in Switzerland to that in Thailand?
Your answer should be very brief. 4.27. What is the ratio of the Imports(as % of merchandise exports) in 1964 in Switzerland to that in Thailand?
Give a very brief answer. 3.59. What is the ratio of the Imports(as % of merchandise exports) of 1965 in Switzerland to that in Thailand?
Provide a short and direct response. 2.07. What is the ratio of the Imports(as % of merchandise exports) of 1962 in Switzerland to that in Turkey?
Keep it short and to the point. 1.22. What is the ratio of the Imports(as % of merchandise exports) in 1963 in Switzerland to that in Turkey?
Ensure brevity in your answer.  1.04. What is the ratio of the Imports(as % of merchandise exports) of 1965 in Switzerland to that in Turkey?
Provide a succinct answer. 0.76. What is the ratio of the Imports(as % of merchandise exports) in 1962 in Switzerland to that in United Kingdom?
Keep it short and to the point. 0.44. What is the ratio of the Imports(as % of merchandise exports) in 1963 in Switzerland to that in United Kingdom?
Give a very brief answer. 0.41. What is the ratio of the Imports(as % of merchandise exports) in 1964 in Switzerland to that in United Kingdom?
Make the answer very short. 0.41. What is the ratio of the Imports(as % of merchandise exports) in 1965 in Switzerland to that in United Kingdom?
Your answer should be compact. 0.41. What is the ratio of the Imports(as % of merchandise exports) of 1962 in Switzerland to that in United States?
Give a very brief answer. 0.62. What is the ratio of the Imports(as % of merchandise exports) of 1963 in Switzerland to that in United States?
Keep it short and to the point. 0.61. What is the ratio of the Imports(as % of merchandise exports) in 1964 in Switzerland to that in United States?
Your answer should be compact. 0.63. What is the ratio of the Imports(as % of merchandise exports) of 1965 in Switzerland to that in United States?
Your answer should be compact. 0.62. What is the ratio of the Imports(as % of merchandise exports) of 1962 in Thailand to that in Turkey?
Ensure brevity in your answer.  0.29. What is the ratio of the Imports(as % of merchandise exports) in 1963 in Thailand to that in Turkey?
Your answer should be very brief. 0.24. What is the ratio of the Imports(as % of merchandise exports) of 1964 in Thailand to that in Turkey?
Your answer should be compact. 0.28. What is the ratio of the Imports(as % of merchandise exports) of 1965 in Thailand to that in Turkey?
Ensure brevity in your answer.  0.37. What is the ratio of the Imports(as % of merchandise exports) in 1962 in Thailand to that in United Kingdom?
Offer a terse response. 0.1. What is the ratio of the Imports(as % of merchandise exports) in 1963 in Thailand to that in United Kingdom?
Give a very brief answer. 0.1. What is the ratio of the Imports(as % of merchandise exports) of 1964 in Thailand to that in United Kingdom?
Provide a succinct answer. 0.11. What is the ratio of the Imports(as % of merchandise exports) in 1965 in Thailand to that in United Kingdom?
Provide a short and direct response. 0.2. What is the ratio of the Imports(as % of merchandise exports) of 1962 in Thailand to that in United States?
Provide a short and direct response. 0.15. What is the ratio of the Imports(as % of merchandise exports) in 1963 in Thailand to that in United States?
Provide a short and direct response. 0.14. What is the ratio of the Imports(as % of merchandise exports) in 1964 in Thailand to that in United States?
Your response must be concise. 0.18. What is the ratio of the Imports(as % of merchandise exports) of 1965 in Thailand to that in United States?
Your answer should be very brief. 0.3. What is the ratio of the Imports(as % of merchandise exports) of 1962 in Turkey to that in United Kingdom?
Ensure brevity in your answer.  0.36. What is the ratio of the Imports(as % of merchandise exports) in 1963 in Turkey to that in United Kingdom?
Give a very brief answer. 0.4. What is the ratio of the Imports(as % of merchandise exports) of 1964 in Turkey to that in United Kingdom?
Provide a short and direct response. 0.41. What is the ratio of the Imports(as % of merchandise exports) of 1965 in Turkey to that in United Kingdom?
Give a very brief answer. 0.54. What is the ratio of the Imports(as % of merchandise exports) in 1962 in Turkey to that in United States?
Provide a short and direct response. 0.51. What is the ratio of the Imports(as % of merchandise exports) of 1963 in Turkey to that in United States?
Your answer should be very brief. 0.58. What is the ratio of the Imports(as % of merchandise exports) in 1964 in Turkey to that in United States?
Your response must be concise. 0.63. What is the ratio of the Imports(as % of merchandise exports) in 1965 in Turkey to that in United States?
Keep it short and to the point. 0.82. What is the ratio of the Imports(as % of merchandise exports) of 1962 in United Kingdom to that in United States?
Your response must be concise. 1.42. What is the ratio of the Imports(as % of merchandise exports) in 1963 in United Kingdom to that in United States?
Provide a succinct answer. 1.46. What is the ratio of the Imports(as % of merchandise exports) of 1964 in United Kingdom to that in United States?
Your answer should be compact. 1.53. What is the ratio of the Imports(as % of merchandise exports) of 1965 in United Kingdom to that in United States?
Provide a succinct answer. 1.51. What is the difference between the highest and the second highest Imports(as % of merchandise exports) in 1962?
Your response must be concise. 4.28. What is the difference between the highest and the second highest Imports(as % of merchandise exports) in 1963?
Provide a succinct answer. 4.68. What is the difference between the highest and the second highest Imports(as % of merchandise exports) of 1964?
Offer a terse response. 4.94. What is the difference between the highest and the second highest Imports(as % of merchandise exports) in 1965?
Your response must be concise. 4.39. What is the difference between the highest and the lowest Imports(as % of merchandise exports) of 1962?
Offer a very short reply. 13.05. What is the difference between the highest and the lowest Imports(as % of merchandise exports) in 1963?
Provide a succinct answer. 13.33. What is the difference between the highest and the lowest Imports(as % of merchandise exports) of 1964?
Provide a short and direct response. 12.65. What is the difference between the highest and the lowest Imports(as % of merchandise exports) in 1965?
Provide a succinct answer. 10.36. 